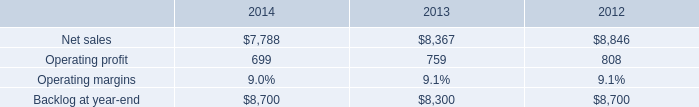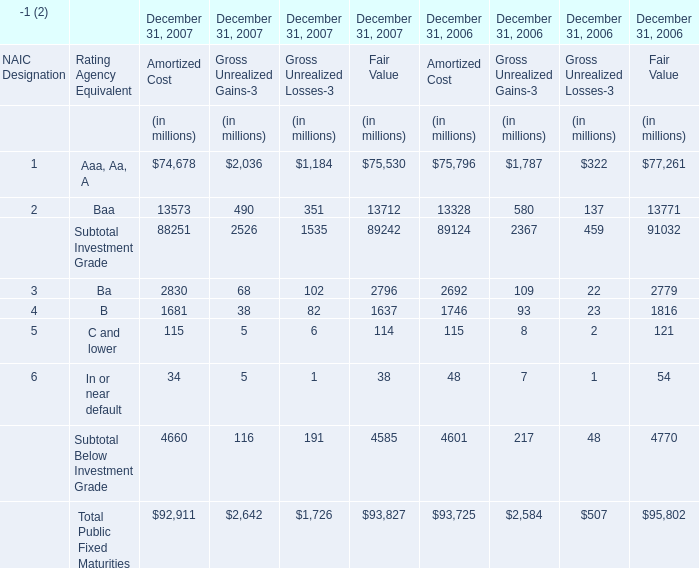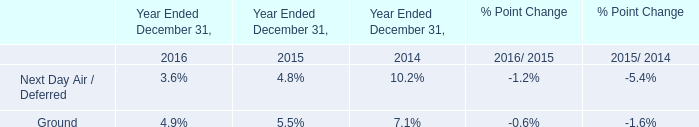what is the growth rate in operating profit from 2013 to 2014 for is&gs? 
Computations: ((699 - 759) / 759)
Answer: -0.07905. 